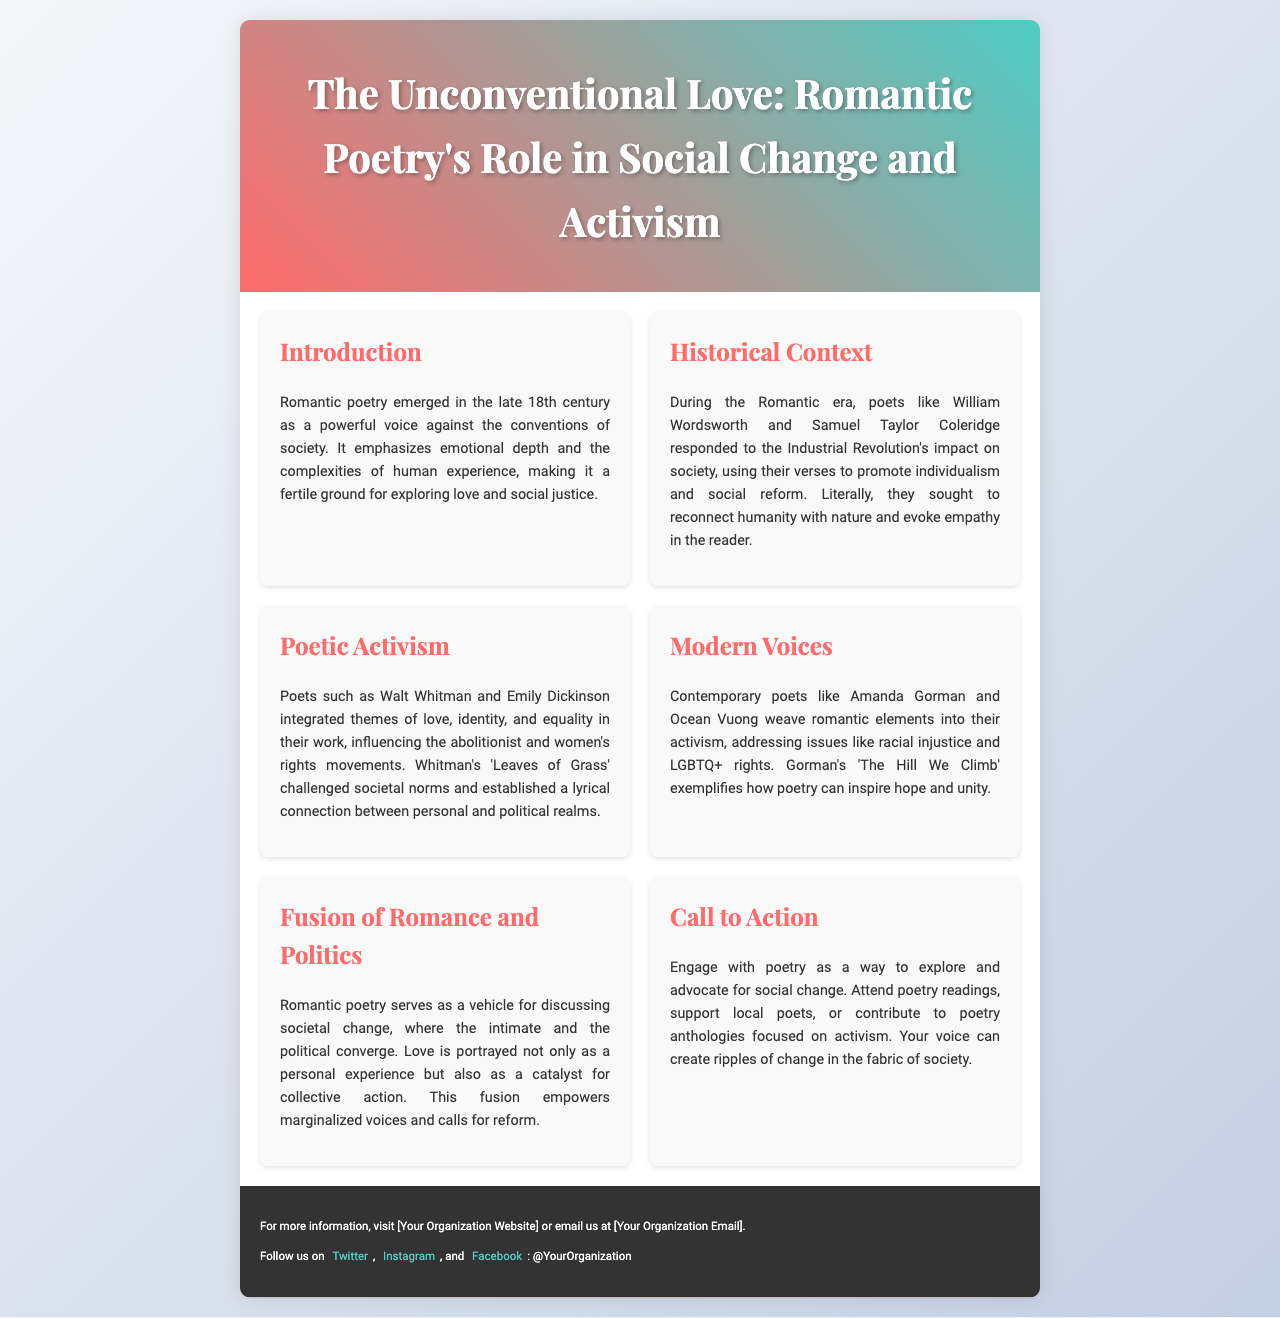what is the title of the brochure? The title is displayed prominently at the top of the brochure.
Answer: The Unconventional Love: Romantic Poetry's Role in Social Change and Activism who are the two poets mentioned in the Historical Context section? The section lists specific poets who contributed during the Romantic era.
Answer: William Wordsworth and Samuel Taylor Coleridge which contemporary poet is mentioned in the Modern Voices section? The section provides names of current poets leading the fusion of poetry and activism.
Answer: Amanda Gorman what literary work by Walt Whitman is referenced in the Poetic Activism section? This section includes the title of a significant work that embodies the themes discussed.
Answer: Leaves of Grass how many sections are there in the brochure? The total number of distinct sections can be counted for an overview of the information included.
Answer: Six what concept is emphasized in the Fusion of Romance and Politics section? The section centers around key ideas that connect literature and societal issues.
Answer: Collective action 